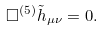Convert formula to latex. <formula><loc_0><loc_0><loc_500><loc_500>\Box ^ { ( 5 ) } \tilde { h } _ { \mu \nu } = 0 .</formula> 